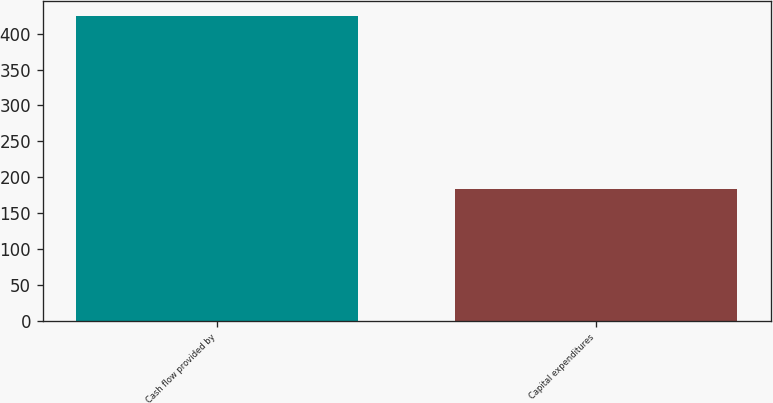Convert chart to OTSL. <chart><loc_0><loc_0><loc_500><loc_500><bar_chart><fcel>Cash flow provided by<fcel>Capital expenditures<nl><fcel>424.4<fcel>183.8<nl></chart> 